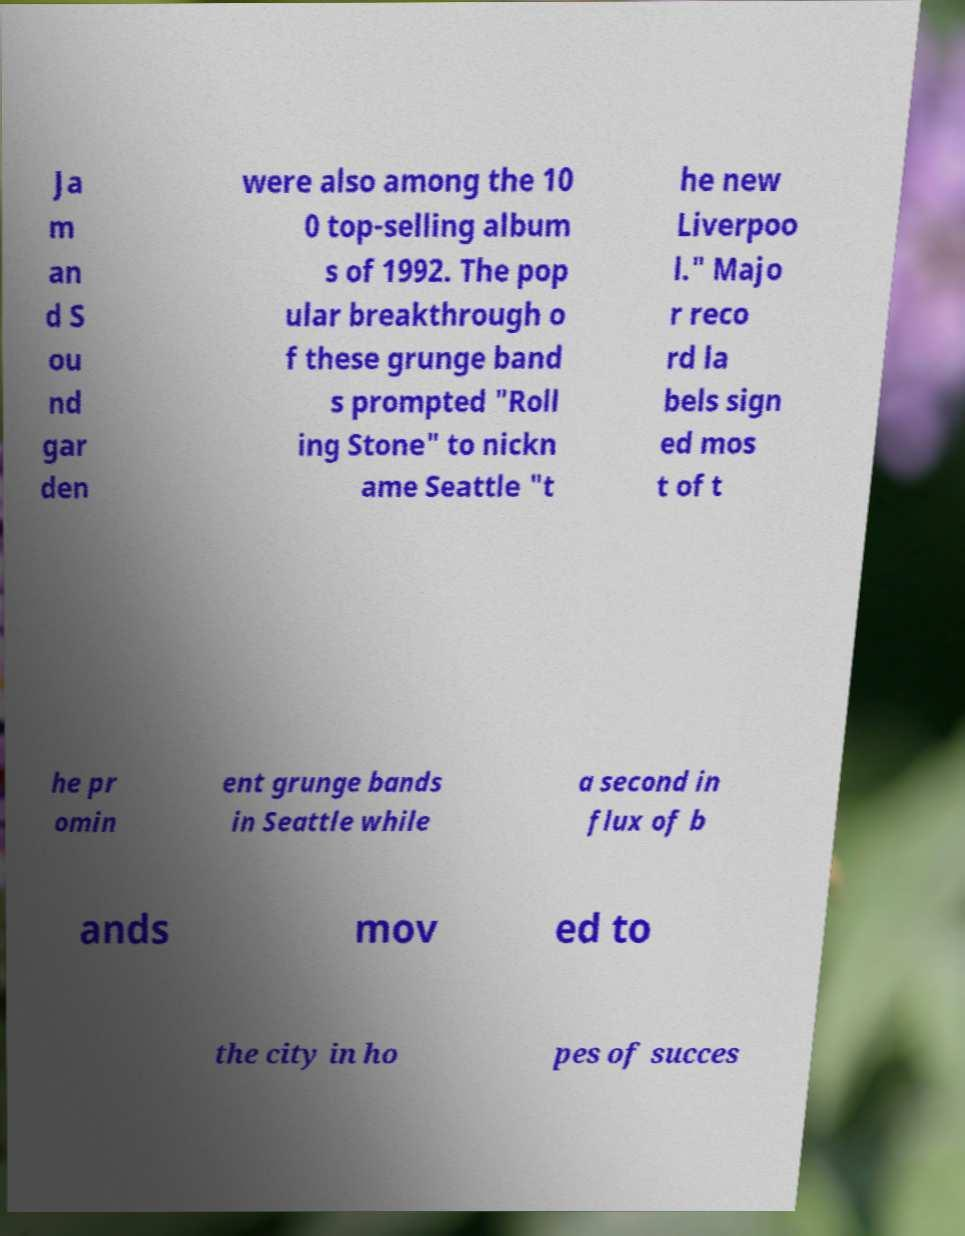Please read and relay the text visible in this image. What does it say? Ja m an d S ou nd gar den were also among the 10 0 top-selling album s of 1992. The pop ular breakthrough o f these grunge band s prompted "Roll ing Stone" to nickn ame Seattle "t he new Liverpoo l." Majo r reco rd la bels sign ed mos t of t he pr omin ent grunge bands in Seattle while a second in flux of b ands mov ed to the city in ho pes of succes 